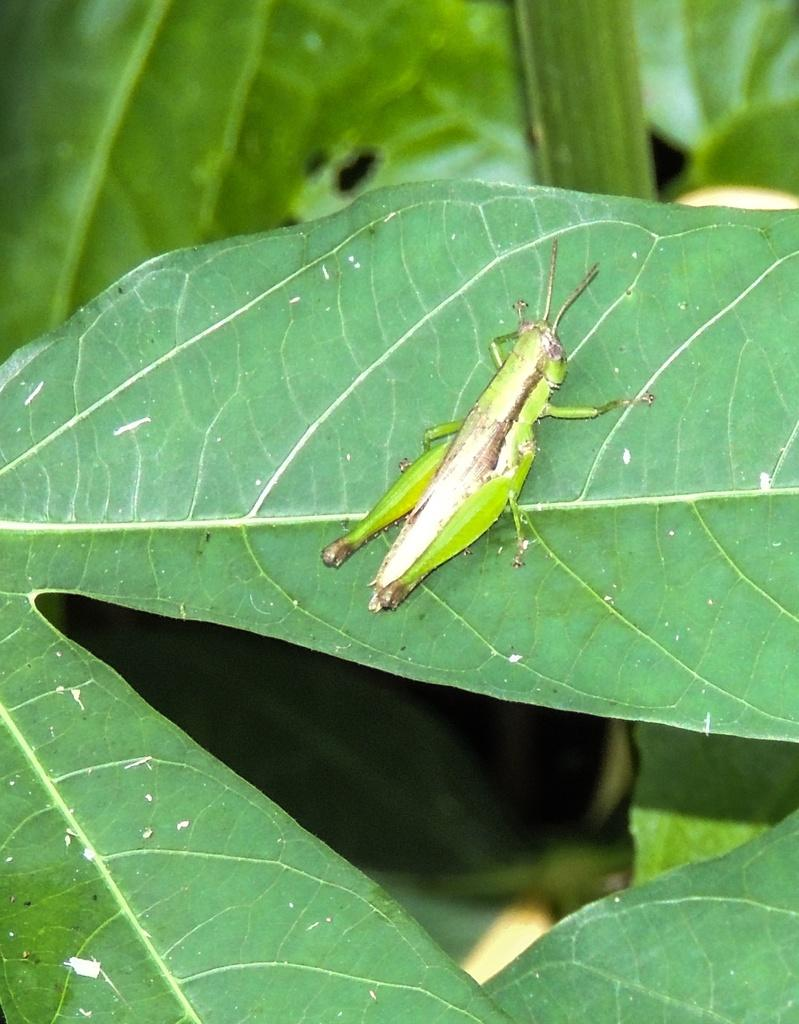What is the main subject of the image? The main subject of the image is a grasshopper. Where is the grasshopper located in the image? The grasshopper is on a leaf in the image. What else can be seen in the image besides the grasshopper? There are leaves on a plant in the image. What type of authority does the grasshopper have in the image? The grasshopper does not have any authority in the image, as it is a grasshopper and not a person or figure of authority. 